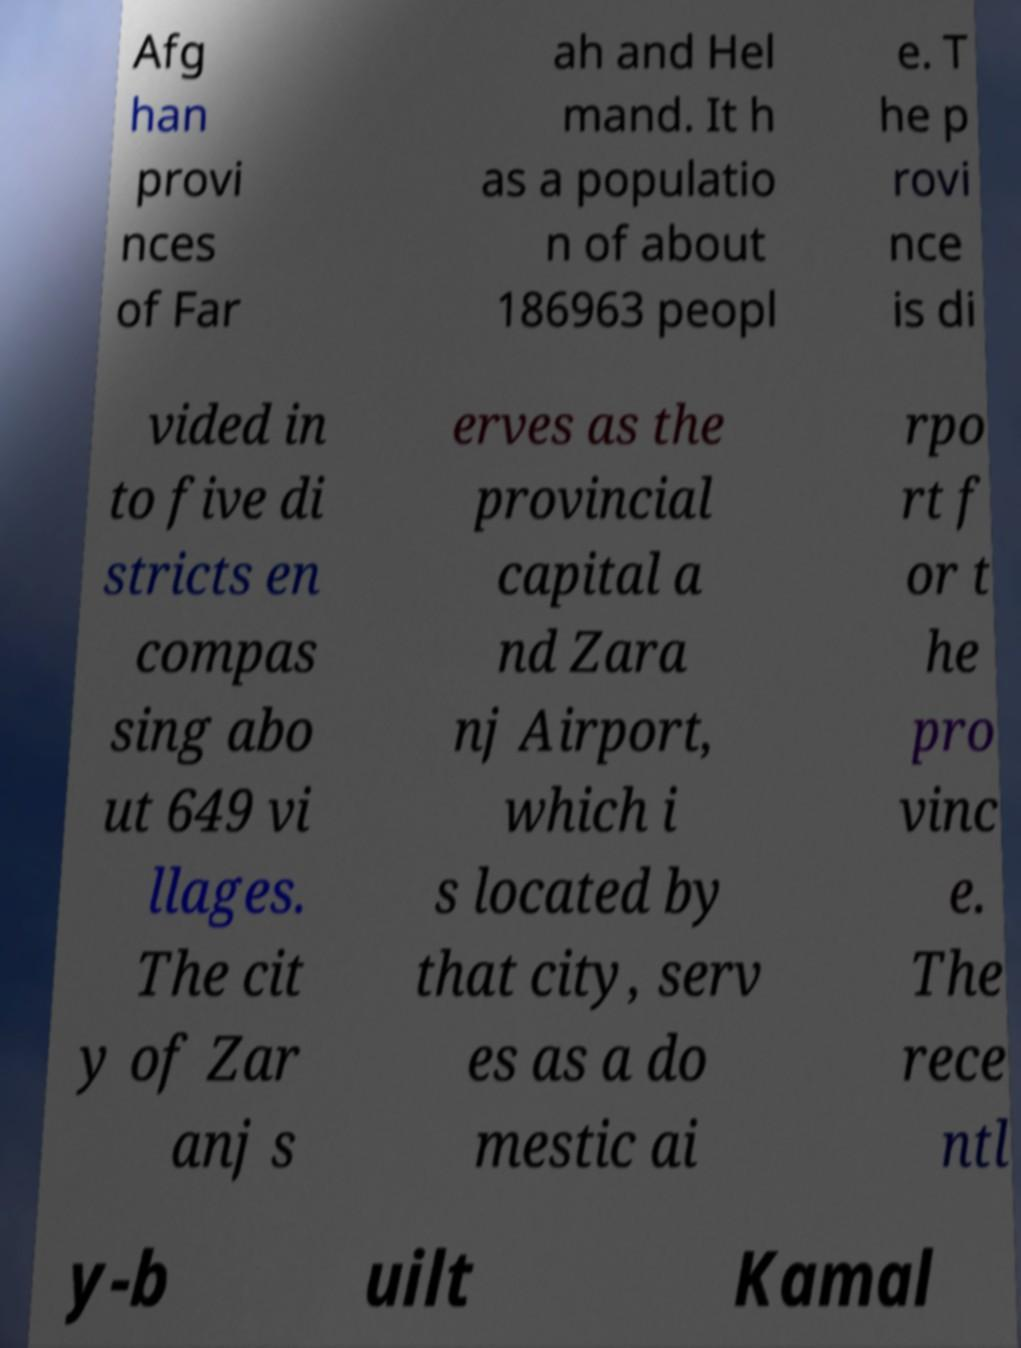Could you assist in decoding the text presented in this image and type it out clearly? Afg han provi nces of Far ah and Hel mand. It h as a populatio n of about 186963 peopl e. T he p rovi nce is di vided in to five di stricts en compas sing abo ut 649 vi llages. The cit y of Zar anj s erves as the provincial capital a nd Zara nj Airport, which i s located by that city, serv es as a do mestic ai rpo rt f or t he pro vinc e. The rece ntl y-b uilt Kamal 